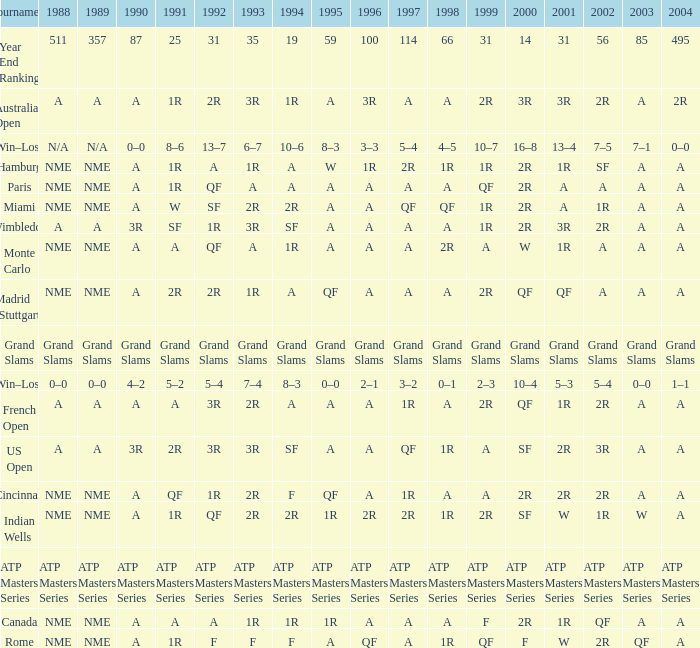What shows for 1992 when 1988 is A, at the Australian Open? 2R. 